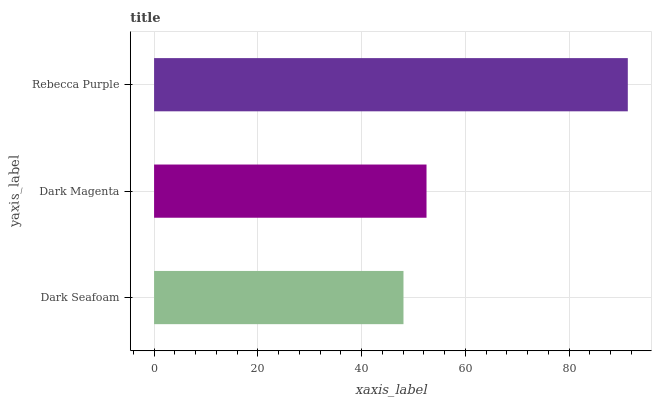Is Dark Seafoam the minimum?
Answer yes or no. Yes. Is Rebecca Purple the maximum?
Answer yes or no. Yes. Is Dark Magenta the minimum?
Answer yes or no. No. Is Dark Magenta the maximum?
Answer yes or no. No. Is Dark Magenta greater than Dark Seafoam?
Answer yes or no. Yes. Is Dark Seafoam less than Dark Magenta?
Answer yes or no. Yes. Is Dark Seafoam greater than Dark Magenta?
Answer yes or no. No. Is Dark Magenta less than Dark Seafoam?
Answer yes or no. No. Is Dark Magenta the high median?
Answer yes or no. Yes. Is Dark Magenta the low median?
Answer yes or no. Yes. Is Dark Seafoam the high median?
Answer yes or no. No. Is Rebecca Purple the low median?
Answer yes or no. No. 